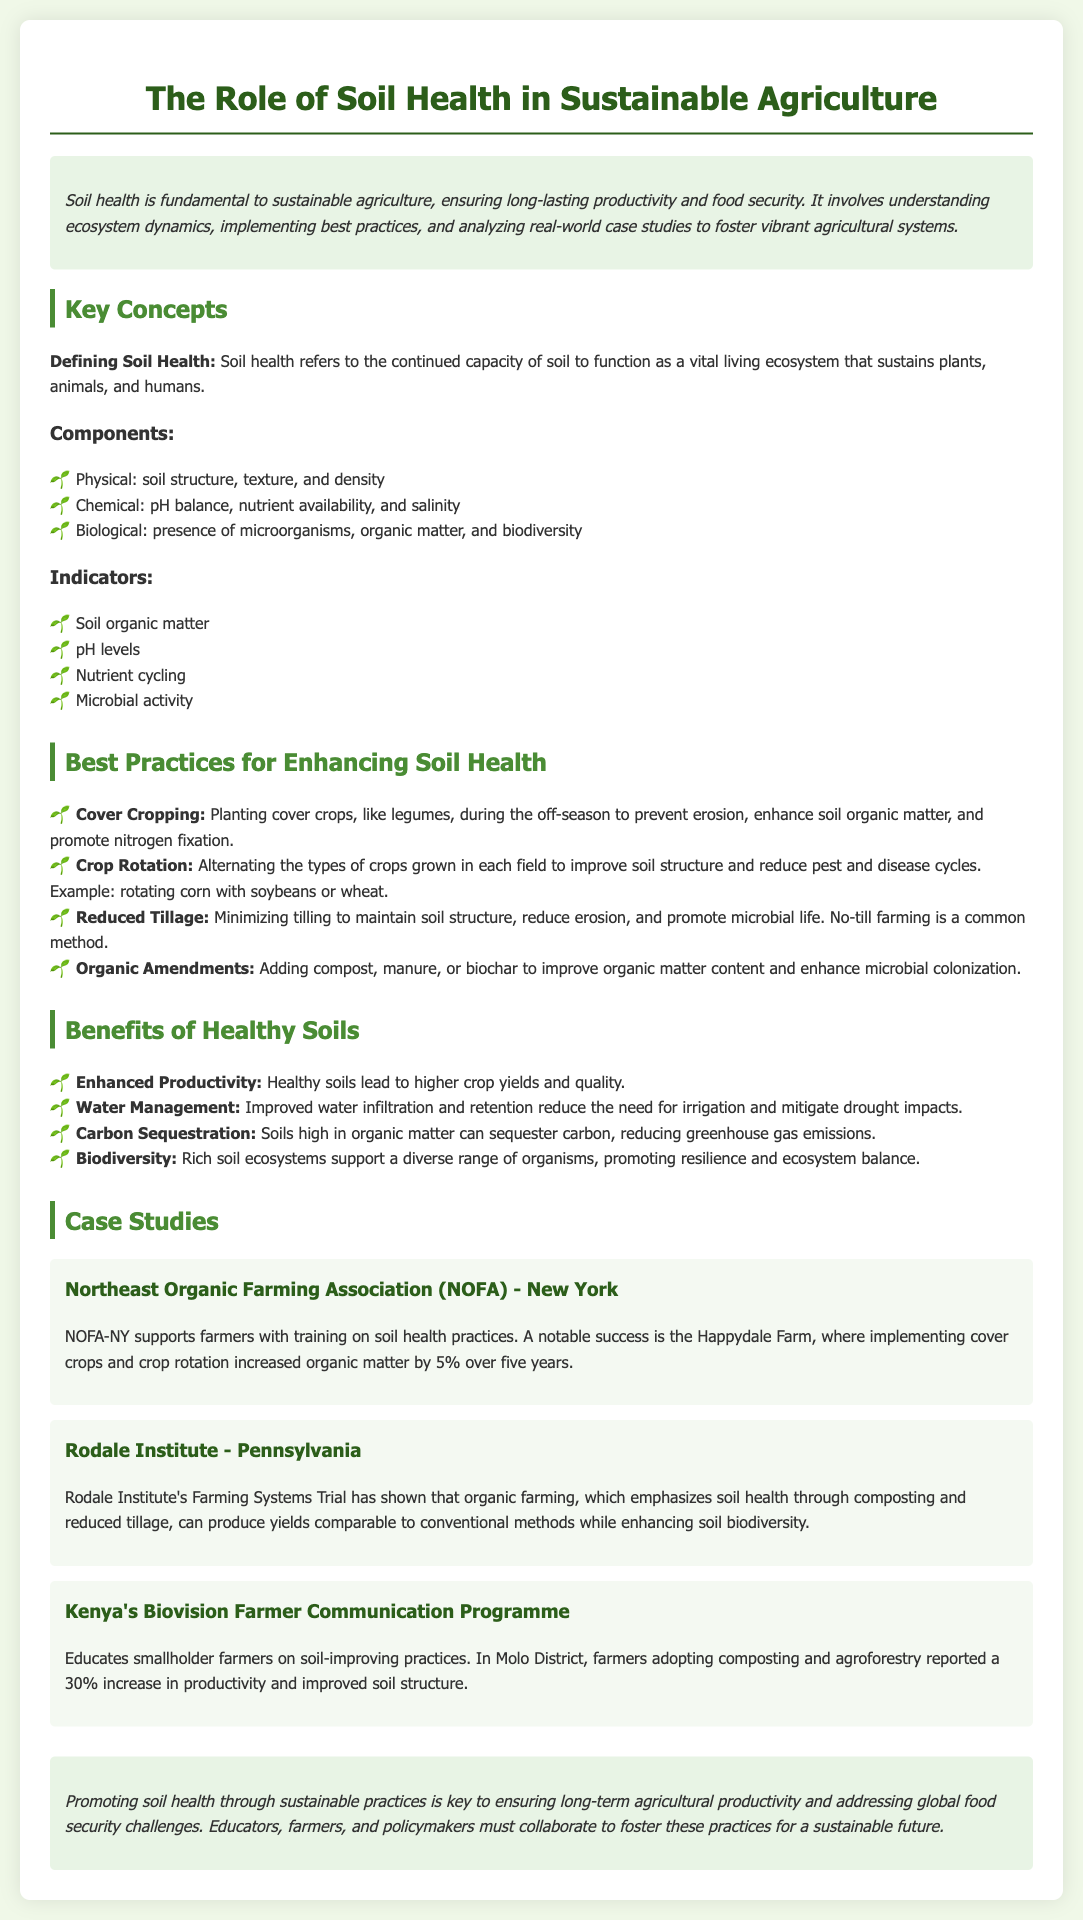What is the title of the fact sheet? The title is presented at the beginning of the document, indicating the focus on soil health in the context of sustainable agriculture.
Answer: The Role of Soil Health in Sustainable Agriculture What are the three components of soil health? The components are listed under the "Components" section, representing the physical, chemical, and biological aspects of soil.
Answer: Physical, Chemical, Biological What is a benefit of healthy soils related to productivity? The benefit is highlighted under the "Benefits of Healthy Soils" section, showing how healthy soils contribute to crop outcomes.
Answer: Enhanced Productivity Which case study involves the Rodale Institute? The case study section contains information about various initiatives, with the Rodale Institute mentioned specifically in Pennsylvania.
Answer: Rodale Institute - Pennsylvania What practice is focused on during the off-season to prevent erosion? The document describes certain practices aimed at enhancing soil health, with cover cropping specifically addressing erosion during the off-season.
Answer: Cover Cropping How much did organic matter increase at the Happydale Farm? This specific information is found in the case study about NOFA-NY, detailing the results over a five-year period.
Answer: 5% What educational program is mentioned that operates in Kenya? The document references a specific farmer communication initiative that operates in Kenya, which is aimed at improving soil practices.
Answer: Biovision Farmer Communication Programme Which sustainable practice minimizes tilling? This practice is discussed in the list of best practices for enhancing soil health, specifically mentioning its impact on soil structure and microbial life.
Answer: Reduced Tillage 